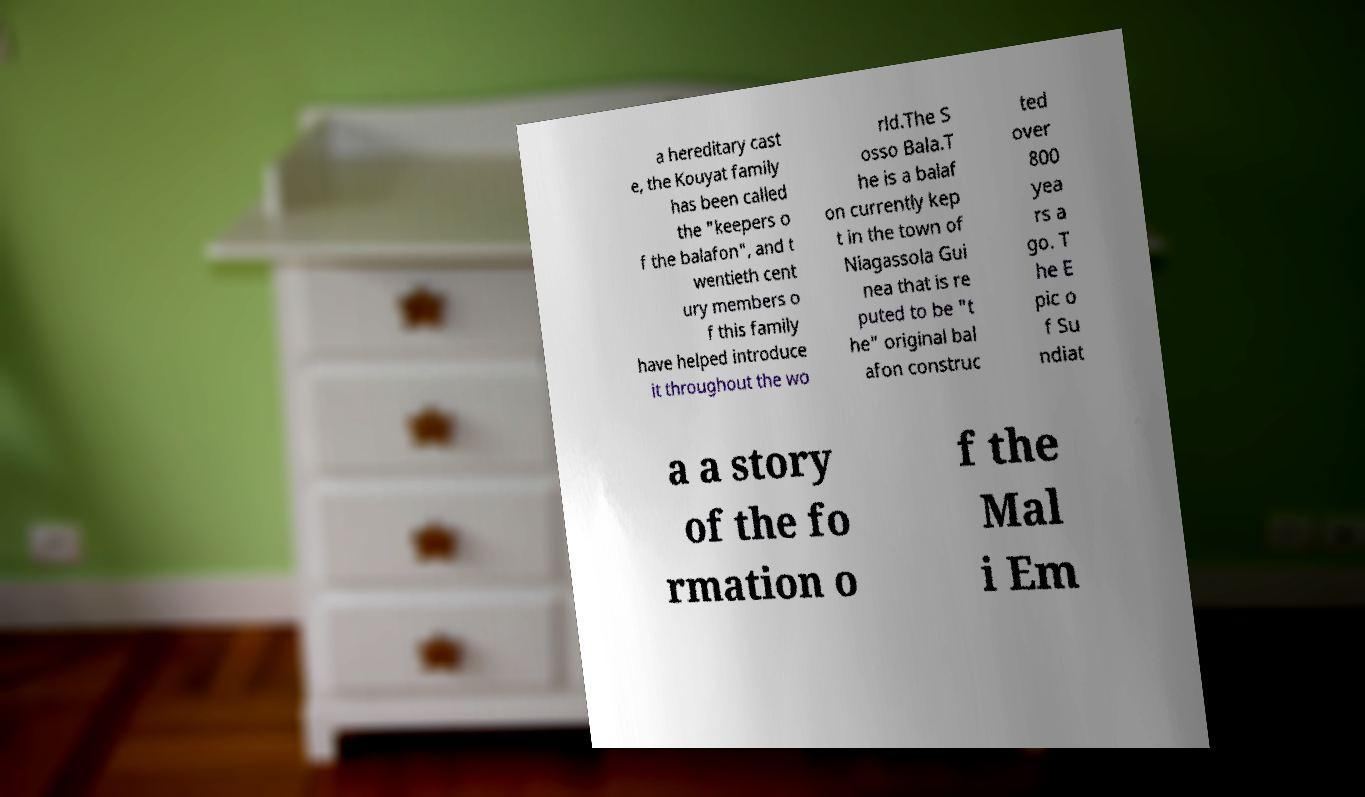Please identify and transcribe the text found in this image. a hereditary cast e, the Kouyat family has been called the "keepers o f the balafon", and t wentieth cent ury members o f this family have helped introduce it throughout the wo rld.The S osso Bala.T he is a balaf on currently kep t in the town of Niagassola Gui nea that is re puted to be "t he" original bal afon construc ted over 800 yea rs a go. T he E pic o f Su ndiat a a story of the fo rmation o f the Mal i Em 